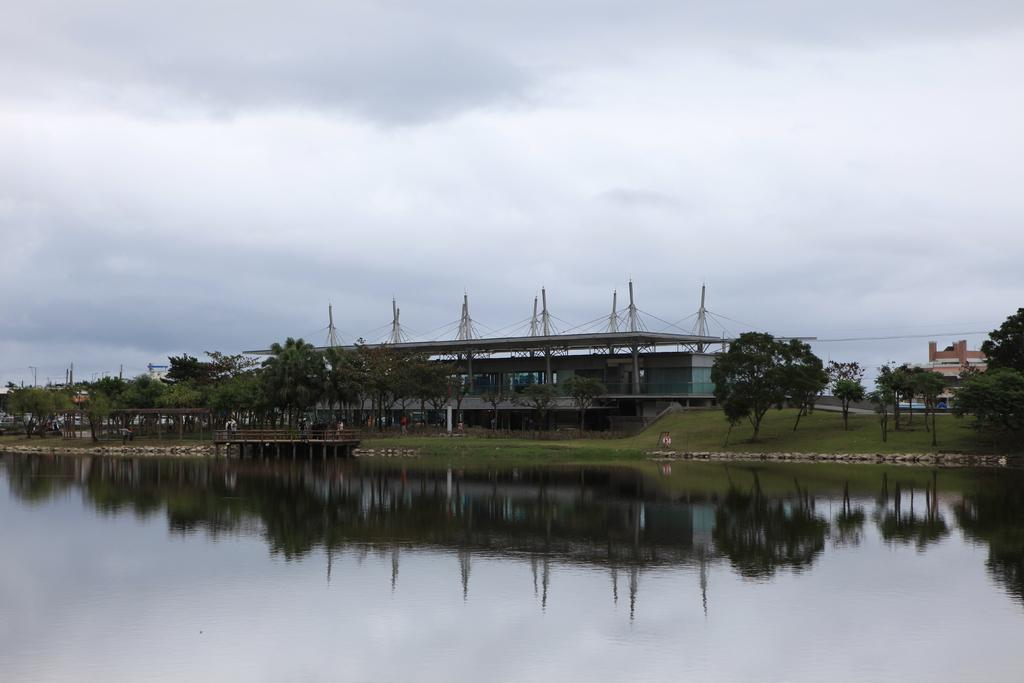What is visible in the image? Water is visible in the image. What can be seen in the background of the image? There are trees, buildings, and poles in the background of the image. What is the color of the trees in the image? The trees are green in color. What is the color of the sky in the image? The sky is visible in the image, with a combination of white and blue colors. What type of sweater is being worn by the water in the image? There is no sweater present in the image, as the main subject is water. 